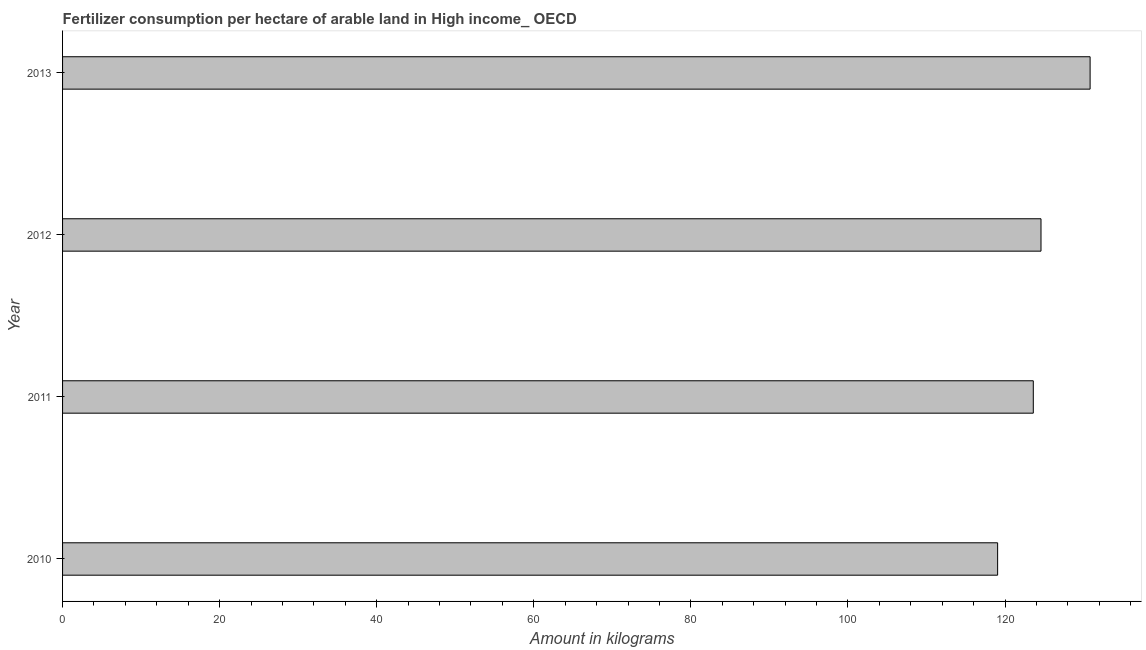Does the graph contain any zero values?
Keep it short and to the point. No. Does the graph contain grids?
Make the answer very short. No. What is the title of the graph?
Offer a very short reply. Fertilizer consumption per hectare of arable land in High income_ OECD . What is the label or title of the X-axis?
Offer a very short reply. Amount in kilograms. What is the amount of fertilizer consumption in 2012?
Keep it short and to the point. 124.58. Across all years, what is the maximum amount of fertilizer consumption?
Give a very brief answer. 130.83. Across all years, what is the minimum amount of fertilizer consumption?
Your answer should be very brief. 119.05. In which year was the amount of fertilizer consumption maximum?
Your response must be concise. 2013. In which year was the amount of fertilizer consumption minimum?
Keep it short and to the point. 2010. What is the sum of the amount of fertilizer consumption?
Your response must be concise. 498.06. What is the difference between the amount of fertilizer consumption in 2011 and 2013?
Ensure brevity in your answer.  -7.23. What is the average amount of fertilizer consumption per year?
Your answer should be compact. 124.52. What is the median amount of fertilizer consumption?
Provide a short and direct response. 124.09. In how many years, is the amount of fertilizer consumption greater than 92 kg?
Your answer should be compact. 4. Do a majority of the years between 2010 and 2013 (inclusive) have amount of fertilizer consumption greater than 96 kg?
Offer a terse response. Yes. What is the ratio of the amount of fertilizer consumption in 2010 to that in 2012?
Ensure brevity in your answer.  0.96. Is the amount of fertilizer consumption in 2011 less than that in 2012?
Your answer should be very brief. Yes. Is the difference between the amount of fertilizer consumption in 2011 and 2012 greater than the difference between any two years?
Offer a terse response. No. What is the difference between the highest and the second highest amount of fertilizer consumption?
Offer a terse response. 6.25. What is the difference between the highest and the lowest amount of fertilizer consumption?
Provide a succinct answer. 11.78. Are all the bars in the graph horizontal?
Keep it short and to the point. Yes. How many years are there in the graph?
Make the answer very short. 4. What is the difference between two consecutive major ticks on the X-axis?
Provide a short and direct response. 20. Are the values on the major ticks of X-axis written in scientific E-notation?
Your answer should be compact. No. What is the Amount in kilograms of 2010?
Make the answer very short. 119.05. What is the Amount in kilograms of 2011?
Keep it short and to the point. 123.6. What is the Amount in kilograms of 2012?
Give a very brief answer. 124.58. What is the Amount in kilograms of 2013?
Offer a terse response. 130.83. What is the difference between the Amount in kilograms in 2010 and 2011?
Your answer should be very brief. -4.54. What is the difference between the Amount in kilograms in 2010 and 2012?
Your answer should be compact. -5.52. What is the difference between the Amount in kilograms in 2010 and 2013?
Your response must be concise. -11.78. What is the difference between the Amount in kilograms in 2011 and 2012?
Make the answer very short. -0.98. What is the difference between the Amount in kilograms in 2011 and 2013?
Your answer should be very brief. -7.23. What is the difference between the Amount in kilograms in 2012 and 2013?
Provide a succinct answer. -6.25. What is the ratio of the Amount in kilograms in 2010 to that in 2011?
Give a very brief answer. 0.96. What is the ratio of the Amount in kilograms in 2010 to that in 2012?
Give a very brief answer. 0.96. What is the ratio of the Amount in kilograms in 2010 to that in 2013?
Your answer should be very brief. 0.91. What is the ratio of the Amount in kilograms in 2011 to that in 2012?
Ensure brevity in your answer.  0.99. What is the ratio of the Amount in kilograms in 2011 to that in 2013?
Give a very brief answer. 0.94. What is the ratio of the Amount in kilograms in 2012 to that in 2013?
Make the answer very short. 0.95. 